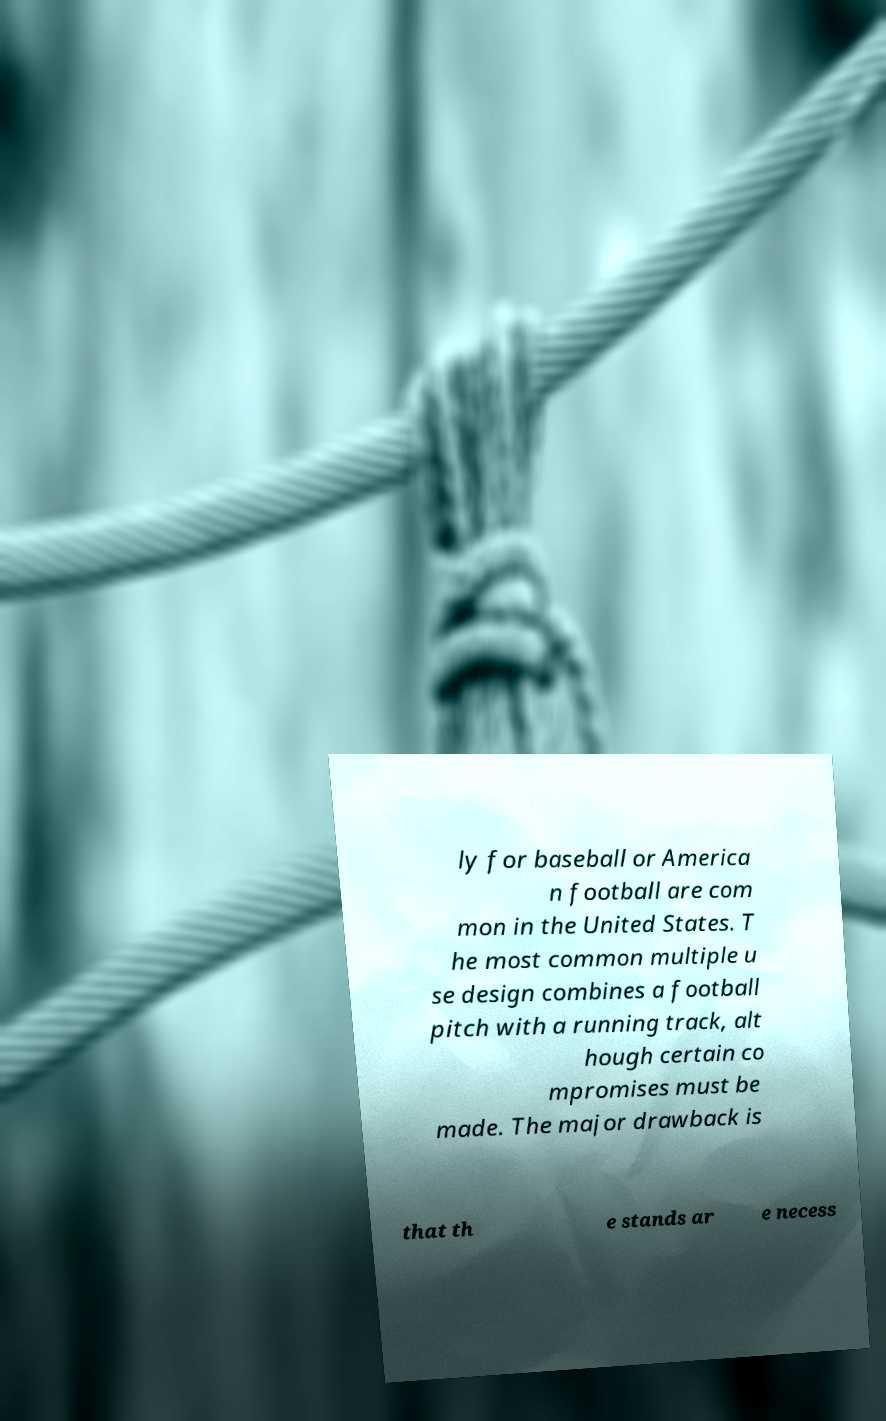Could you extract and type out the text from this image? ly for baseball or America n football are com mon in the United States. T he most common multiple u se design combines a football pitch with a running track, alt hough certain co mpromises must be made. The major drawback is that th e stands ar e necess 